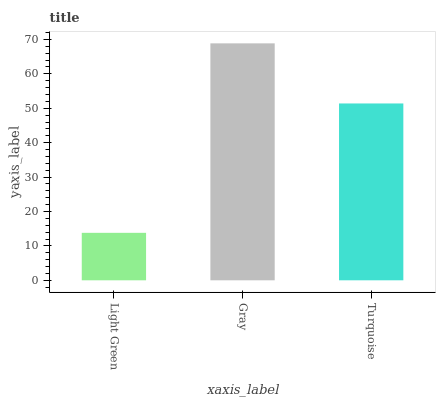Is Light Green the minimum?
Answer yes or no. Yes. Is Gray the maximum?
Answer yes or no. Yes. Is Turquoise the minimum?
Answer yes or no. No. Is Turquoise the maximum?
Answer yes or no. No. Is Gray greater than Turquoise?
Answer yes or no. Yes. Is Turquoise less than Gray?
Answer yes or no. Yes. Is Turquoise greater than Gray?
Answer yes or no. No. Is Gray less than Turquoise?
Answer yes or no. No. Is Turquoise the high median?
Answer yes or no. Yes. Is Turquoise the low median?
Answer yes or no. Yes. Is Gray the high median?
Answer yes or no. No. Is Light Green the low median?
Answer yes or no. No. 